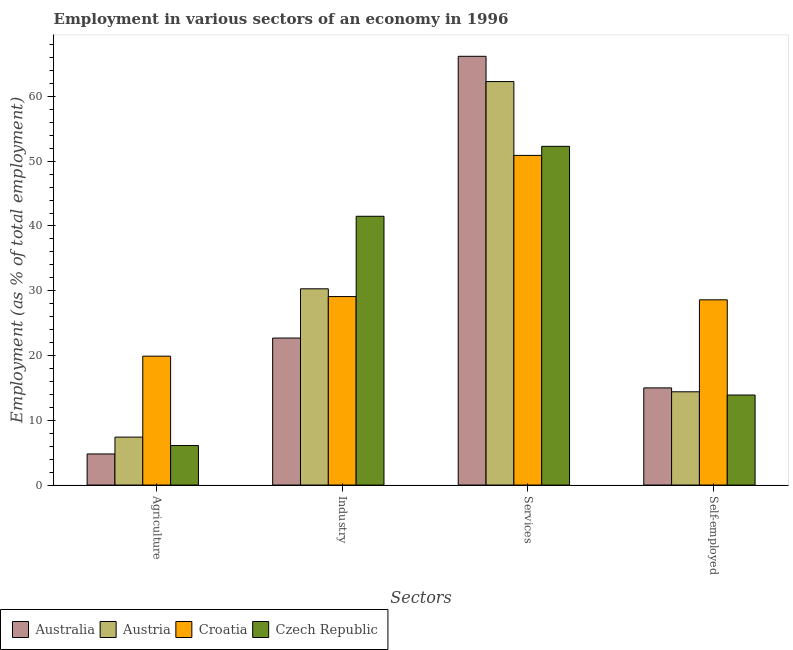Are the number of bars per tick equal to the number of legend labels?
Keep it short and to the point. Yes. How many bars are there on the 1st tick from the left?
Give a very brief answer. 4. How many bars are there on the 4th tick from the right?
Provide a succinct answer. 4. What is the label of the 2nd group of bars from the left?
Keep it short and to the point. Industry. What is the percentage of workers in agriculture in Australia?
Your answer should be very brief. 4.8. Across all countries, what is the maximum percentage of self employed workers?
Your response must be concise. 28.6. Across all countries, what is the minimum percentage of workers in agriculture?
Offer a terse response. 4.8. In which country was the percentage of workers in industry maximum?
Your answer should be very brief. Czech Republic. In which country was the percentage of workers in agriculture minimum?
Provide a succinct answer. Australia. What is the total percentage of self employed workers in the graph?
Give a very brief answer. 71.9. What is the difference between the percentage of self employed workers in Croatia and that in Czech Republic?
Ensure brevity in your answer.  14.7. What is the difference between the percentage of workers in industry in Australia and the percentage of workers in agriculture in Czech Republic?
Make the answer very short. 16.6. What is the average percentage of self employed workers per country?
Your answer should be compact. 17.97. What is the difference between the percentage of workers in services and percentage of self employed workers in Australia?
Your answer should be very brief. 51.2. In how many countries, is the percentage of workers in services greater than 40 %?
Your answer should be very brief. 4. What is the ratio of the percentage of workers in services in Czech Republic to that in Australia?
Your response must be concise. 0.79. What is the difference between the highest and the second highest percentage of self employed workers?
Provide a short and direct response. 13.6. What is the difference between the highest and the lowest percentage of self employed workers?
Your response must be concise. 14.7. In how many countries, is the percentage of workers in services greater than the average percentage of workers in services taken over all countries?
Your answer should be very brief. 2. Is the sum of the percentage of workers in industry in Croatia and Australia greater than the maximum percentage of workers in agriculture across all countries?
Your response must be concise. Yes. Is it the case that in every country, the sum of the percentage of workers in agriculture and percentage of workers in industry is greater than the sum of percentage of self employed workers and percentage of workers in services?
Your answer should be compact. No. Is it the case that in every country, the sum of the percentage of workers in agriculture and percentage of workers in industry is greater than the percentage of workers in services?
Your answer should be very brief. No. How many bars are there?
Provide a short and direct response. 16. How many countries are there in the graph?
Give a very brief answer. 4. What is the difference between two consecutive major ticks on the Y-axis?
Your response must be concise. 10. Does the graph contain any zero values?
Offer a terse response. No. Does the graph contain grids?
Offer a terse response. No. Where does the legend appear in the graph?
Make the answer very short. Bottom left. How many legend labels are there?
Provide a succinct answer. 4. What is the title of the graph?
Your response must be concise. Employment in various sectors of an economy in 1996. Does "Lower middle income" appear as one of the legend labels in the graph?
Ensure brevity in your answer.  No. What is the label or title of the X-axis?
Offer a very short reply. Sectors. What is the label or title of the Y-axis?
Offer a terse response. Employment (as % of total employment). What is the Employment (as % of total employment) of Australia in Agriculture?
Your answer should be compact. 4.8. What is the Employment (as % of total employment) of Austria in Agriculture?
Your answer should be very brief. 7.4. What is the Employment (as % of total employment) in Croatia in Agriculture?
Your answer should be very brief. 19.9. What is the Employment (as % of total employment) in Czech Republic in Agriculture?
Your answer should be very brief. 6.1. What is the Employment (as % of total employment) of Australia in Industry?
Offer a very short reply. 22.7. What is the Employment (as % of total employment) in Austria in Industry?
Provide a short and direct response. 30.3. What is the Employment (as % of total employment) in Croatia in Industry?
Ensure brevity in your answer.  29.1. What is the Employment (as % of total employment) in Czech Republic in Industry?
Provide a short and direct response. 41.5. What is the Employment (as % of total employment) of Australia in Services?
Keep it short and to the point. 66.2. What is the Employment (as % of total employment) of Austria in Services?
Keep it short and to the point. 62.3. What is the Employment (as % of total employment) in Croatia in Services?
Offer a very short reply. 50.9. What is the Employment (as % of total employment) of Czech Republic in Services?
Provide a short and direct response. 52.3. What is the Employment (as % of total employment) in Austria in Self-employed?
Your answer should be compact. 14.4. What is the Employment (as % of total employment) in Croatia in Self-employed?
Your response must be concise. 28.6. What is the Employment (as % of total employment) in Czech Republic in Self-employed?
Offer a very short reply. 13.9. Across all Sectors, what is the maximum Employment (as % of total employment) of Australia?
Give a very brief answer. 66.2. Across all Sectors, what is the maximum Employment (as % of total employment) in Austria?
Ensure brevity in your answer.  62.3. Across all Sectors, what is the maximum Employment (as % of total employment) of Croatia?
Ensure brevity in your answer.  50.9. Across all Sectors, what is the maximum Employment (as % of total employment) in Czech Republic?
Your answer should be very brief. 52.3. Across all Sectors, what is the minimum Employment (as % of total employment) of Australia?
Ensure brevity in your answer.  4.8. Across all Sectors, what is the minimum Employment (as % of total employment) of Austria?
Give a very brief answer. 7.4. Across all Sectors, what is the minimum Employment (as % of total employment) of Croatia?
Your response must be concise. 19.9. Across all Sectors, what is the minimum Employment (as % of total employment) in Czech Republic?
Give a very brief answer. 6.1. What is the total Employment (as % of total employment) of Australia in the graph?
Provide a succinct answer. 108.7. What is the total Employment (as % of total employment) of Austria in the graph?
Provide a short and direct response. 114.4. What is the total Employment (as % of total employment) in Croatia in the graph?
Your answer should be very brief. 128.5. What is the total Employment (as % of total employment) of Czech Republic in the graph?
Offer a very short reply. 113.8. What is the difference between the Employment (as % of total employment) of Australia in Agriculture and that in Industry?
Your answer should be very brief. -17.9. What is the difference between the Employment (as % of total employment) of Austria in Agriculture and that in Industry?
Your response must be concise. -22.9. What is the difference between the Employment (as % of total employment) of Croatia in Agriculture and that in Industry?
Your answer should be compact. -9.2. What is the difference between the Employment (as % of total employment) in Czech Republic in Agriculture and that in Industry?
Keep it short and to the point. -35.4. What is the difference between the Employment (as % of total employment) of Australia in Agriculture and that in Services?
Your answer should be compact. -61.4. What is the difference between the Employment (as % of total employment) in Austria in Agriculture and that in Services?
Offer a terse response. -54.9. What is the difference between the Employment (as % of total employment) in Croatia in Agriculture and that in Services?
Ensure brevity in your answer.  -31. What is the difference between the Employment (as % of total employment) in Czech Republic in Agriculture and that in Services?
Provide a short and direct response. -46.2. What is the difference between the Employment (as % of total employment) of Australia in Agriculture and that in Self-employed?
Offer a very short reply. -10.2. What is the difference between the Employment (as % of total employment) in Croatia in Agriculture and that in Self-employed?
Your response must be concise. -8.7. What is the difference between the Employment (as % of total employment) in Australia in Industry and that in Services?
Keep it short and to the point. -43.5. What is the difference between the Employment (as % of total employment) of Austria in Industry and that in Services?
Provide a succinct answer. -32. What is the difference between the Employment (as % of total employment) of Croatia in Industry and that in Services?
Ensure brevity in your answer.  -21.8. What is the difference between the Employment (as % of total employment) of Croatia in Industry and that in Self-employed?
Make the answer very short. 0.5. What is the difference between the Employment (as % of total employment) in Czech Republic in Industry and that in Self-employed?
Offer a very short reply. 27.6. What is the difference between the Employment (as % of total employment) of Australia in Services and that in Self-employed?
Provide a short and direct response. 51.2. What is the difference between the Employment (as % of total employment) in Austria in Services and that in Self-employed?
Provide a succinct answer. 47.9. What is the difference between the Employment (as % of total employment) in Croatia in Services and that in Self-employed?
Give a very brief answer. 22.3. What is the difference between the Employment (as % of total employment) in Czech Republic in Services and that in Self-employed?
Ensure brevity in your answer.  38.4. What is the difference between the Employment (as % of total employment) in Australia in Agriculture and the Employment (as % of total employment) in Austria in Industry?
Your response must be concise. -25.5. What is the difference between the Employment (as % of total employment) of Australia in Agriculture and the Employment (as % of total employment) of Croatia in Industry?
Ensure brevity in your answer.  -24.3. What is the difference between the Employment (as % of total employment) in Australia in Agriculture and the Employment (as % of total employment) in Czech Republic in Industry?
Offer a very short reply. -36.7. What is the difference between the Employment (as % of total employment) in Austria in Agriculture and the Employment (as % of total employment) in Croatia in Industry?
Your response must be concise. -21.7. What is the difference between the Employment (as % of total employment) of Austria in Agriculture and the Employment (as % of total employment) of Czech Republic in Industry?
Provide a succinct answer. -34.1. What is the difference between the Employment (as % of total employment) in Croatia in Agriculture and the Employment (as % of total employment) in Czech Republic in Industry?
Provide a short and direct response. -21.6. What is the difference between the Employment (as % of total employment) in Australia in Agriculture and the Employment (as % of total employment) in Austria in Services?
Your response must be concise. -57.5. What is the difference between the Employment (as % of total employment) of Australia in Agriculture and the Employment (as % of total employment) of Croatia in Services?
Make the answer very short. -46.1. What is the difference between the Employment (as % of total employment) of Australia in Agriculture and the Employment (as % of total employment) of Czech Republic in Services?
Your answer should be compact. -47.5. What is the difference between the Employment (as % of total employment) of Austria in Agriculture and the Employment (as % of total employment) of Croatia in Services?
Your answer should be very brief. -43.5. What is the difference between the Employment (as % of total employment) of Austria in Agriculture and the Employment (as % of total employment) of Czech Republic in Services?
Your answer should be very brief. -44.9. What is the difference between the Employment (as % of total employment) of Croatia in Agriculture and the Employment (as % of total employment) of Czech Republic in Services?
Your response must be concise. -32.4. What is the difference between the Employment (as % of total employment) in Australia in Agriculture and the Employment (as % of total employment) in Croatia in Self-employed?
Offer a very short reply. -23.8. What is the difference between the Employment (as % of total employment) in Australia in Agriculture and the Employment (as % of total employment) in Czech Republic in Self-employed?
Your answer should be very brief. -9.1. What is the difference between the Employment (as % of total employment) in Austria in Agriculture and the Employment (as % of total employment) in Croatia in Self-employed?
Ensure brevity in your answer.  -21.2. What is the difference between the Employment (as % of total employment) in Austria in Agriculture and the Employment (as % of total employment) in Czech Republic in Self-employed?
Ensure brevity in your answer.  -6.5. What is the difference between the Employment (as % of total employment) in Australia in Industry and the Employment (as % of total employment) in Austria in Services?
Your answer should be compact. -39.6. What is the difference between the Employment (as % of total employment) in Australia in Industry and the Employment (as % of total employment) in Croatia in Services?
Keep it short and to the point. -28.2. What is the difference between the Employment (as % of total employment) of Australia in Industry and the Employment (as % of total employment) of Czech Republic in Services?
Provide a succinct answer. -29.6. What is the difference between the Employment (as % of total employment) in Austria in Industry and the Employment (as % of total employment) in Croatia in Services?
Offer a very short reply. -20.6. What is the difference between the Employment (as % of total employment) of Austria in Industry and the Employment (as % of total employment) of Czech Republic in Services?
Ensure brevity in your answer.  -22. What is the difference between the Employment (as % of total employment) of Croatia in Industry and the Employment (as % of total employment) of Czech Republic in Services?
Offer a very short reply. -23.2. What is the difference between the Employment (as % of total employment) in Australia in Industry and the Employment (as % of total employment) in Austria in Self-employed?
Offer a very short reply. 8.3. What is the difference between the Employment (as % of total employment) of Australia in Industry and the Employment (as % of total employment) of Croatia in Self-employed?
Make the answer very short. -5.9. What is the difference between the Employment (as % of total employment) in Croatia in Industry and the Employment (as % of total employment) in Czech Republic in Self-employed?
Provide a succinct answer. 15.2. What is the difference between the Employment (as % of total employment) of Australia in Services and the Employment (as % of total employment) of Austria in Self-employed?
Provide a short and direct response. 51.8. What is the difference between the Employment (as % of total employment) of Australia in Services and the Employment (as % of total employment) of Croatia in Self-employed?
Provide a succinct answer. 37.6. What is the difference between the Employment (as % of total employment) in Australia in Services and the Employment (as % of total employment) in Czech Republic in Self-employed?
Your response must be concise. 52.3. What is the difference between the Employment (as % of total employment) in Austria in Services and the Employment (as % of total employment) in Croatia in Self-employed?
Your response must be concise. 33.7. What is the difference between the Employment (as % of total employment) in Austria in Services and the Employment (as % of total employment) in Czech Republic in Self-employed?
Your response must be concise. 48.4. What is the difference between the Employment (as % of total employment) of Croatia in Services and the Employment (as % of total employment) of Czech Republic in Self-employed?
Keep it short and to the point. 37. What is the average Employment (as % of total employment) in Australia per Sectors?
Your answer should be compact. 27.18. What is the average Employment (as % of total employment) in Austria per Sectors?
Make the answer very short. 28.6. What is the average Employment (as % of total employment) in Croatia per Sectors?
Provide a succinct answer. 32.12. What is the average Employment (as % of total employment) of Czech Republic per Sectors?
Provide a succinct answer. 28.45. What is the difference between the Employment (as % of total employment) of Australia and Employment (as % of total employment) of Croatia in Agriculture?
Offer a very short reply. -15.1. What is the difference between the Employment (as % of total employment) in Australia and Employment (as % of total employment) in Czech Republic in Agriculture?
Give a very brief answer. -1.3. What is the difference between the Employment (as % of total employment) in Austria and Employment (as % of total employment) in Croatia in Agriculture?
Your answer should be compact. -12.5. What is the difference between the Employment (as % of total employment) of Australia and Employment (as % of total employment) of Austria in Industry?
Make the answer very short. -7.6. What is the difference between the Employment (as % of total employment) in Australia and Employment (as % of total employment) in Czech Republic in Industry?
Give a very brief answer. -18.8. What is the difference between the Employment (as % of total employment) in Croatia and Employment (as % of total employment) in Czech Republic in Industry?
Provide a succinct answer. -12.4. What is the difference between the Employment (as % of total employment) in Australia and Employment (as % of total employment) in Austria in Services?
Provide a short and direct response. 3.9. What is the difference between the Employment (as % of total employment) in Australia and Employment (as % of total employment) in Croatia in Services?
Offer a terse response. 15.3. What is the difference between the Employment (as % of total employment) of Australia and Employment (as % of total employment) of Czech Republic in Services?
Offer a terse response. 13.9. What is the difference between the Employment (as % of total employment) of Austria and Employment (as % of total employment) of Croatia in Self-employed?
Give a very brief answer. -14.2. What is the ratio of the Employment (as % of total employment) of Australia in Agriculture to that in Industry?
Keep it short and to the point. 0.21. What is the ratio of the Employment (as % of total employment) in Austria in Agriculture to that in Industry?
Your answer should be compact. 0.24. What is the ratio of the Employment (as % of total employment) in Croatia in Agriculture to that in Industry?
Provide a succinct answer. 0.68. What is the ratio of the Employment (as % of total employment) in Czech Republic in Agriculture to that in Industry?
Offer a terse response. 0.15. What is the ratio of the Employment (as % of total employment) of Australia in Agriculture to that in Services?
Keep it short and to the point. 0.07. What is the ratio of the Employment (as % of total employment) of Austria in Agriculture to that in Services?
Your response must be concise. 0.12. What is the ratio of the Employment (as % of total employment) in Croatia in Agriculture to that in Services?
Keep it short and to the point. 0.39. What is the ratio of the Employment (as % of total employment) of Czech Republic in Agriculture to that in Services?
Ensure brevity in your answer.  0.12. What is the ratio of the Employment (as % of total employment) in Australia in Agriculture to that in Self-employed?
Provide a short and direct response. 0.32. What is the ratio of the Employment (as % of total employment) of Austria in Agriculture to that in Self-employed?
Offer a very short reply. 0.51. What is the ratio of the Employment (as % of total employment) of Croatia in Agriculture to that in Self-employed?
Ensure brevity in your answer.  0.7. What is the ratio of the Employment (as % of total employment) of Czech Republic in Agriculture to that in Self-employed?
Your response must be concise. 0.44. What is the ratio of the Employment (as % of total employment) of Australia in Industry to that in Services?
Your answer should be very brief. 0.34. What is the ratio of the Employment (as % of total employment) of Austria in Industry to that in Services?
Keep it short and to the point. 0.49. What is the ratio of the Employment (as % of total employment) in Croatia in Industry to that in Services?
Offer a very short reply. 0.57. What is the ratio of the Employment (as % of total employment) of Czech Republic in Industry to that in Services?
Keep it short and to the point. 0.79. What is the ratio of the Employment (as % of total employment) of Australia in Industry to that in Self-employed?
Your answer should be very brief. 1.51. What is the ratio of the Employment (as % of total employment) in Austria in Industry to that in Self-employed?
Your answer should be very brief. 2.1. What is the ratio of the Employment (as % of total employment) of Croatia in Industry to that in Self-employed?
Your response must be concise. 1.02. What is the ratio of the Employment (as % of total employment) of Czech Republic in Industry to that in Self-employed?
Give a very brief answer. 2.99. What is the ratio of the Employment (as % of total employment) in Australia in Services to that in Self-employed?
Keep it short and to the point. 4.41. What is the ratio of the Employment (as % of total employment) in Austria in Services to that in Self-employed?
Give a very brief answer. 4.33. What is the ratio of the Employment (as % of total employment) of Croatia in Services to that in Self-employed?
Your response must be concise. 1.78. What is the ratio of the Employment (as % of total employment) in Czech Republic in Services to that in Self-employed?
Your answer should be very brief. 3.76. What is the difference between the highest and the second highest Employment (as % of total employment) of Australia?
Your answer should be compact. 43.5. What is the difference between the highest and the second highest Employment (as % of total employment) in Croatia?
Offer a terse response. 21.8. What is the difference between the highest and the second highest Employment (as % of total employment) in Czech Republic?
Keep it short and to the point. 10.8. What is the difference between the highest and the lowest Employment (as % of total employment) of Australia?
Your answer should be compact. 61.4. What is the difference between the highest and the lowest Employment (as % of total employment) in Austria?
Keep it short and to the point. 54.9. What is the difference between the highest and the lowest Employment (as % of total employment) in Croatia?
Make the answer very short. 31. What is the difference between the highest and the lowest Employment (as % of total employment) in Czech Republic?
Your answer should be very brief. 46.2. 